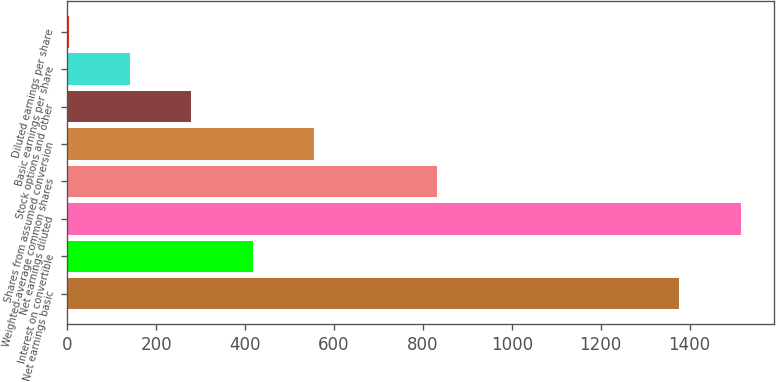Convert chart to OTSL. <chart><loc_0><loc_0><loc_500><loc_500><bar_chart><fcel>Net earnings basic<fcel>Interest on convertible<fcel>Net earnings diluted<fcel>Weighted-average common shares<fcel>Shares from assumed conversion<fcel>Stock options and other<fcel>Basic earnings per share<fcel>Diluted earnings per share<nl><fcel>1377<fcel>417.15<fcel>1515.12<fcel>831.51<fcel>555.27<fcel>279.03<fcel>140.91<fcel>2.79<nl></chart> 